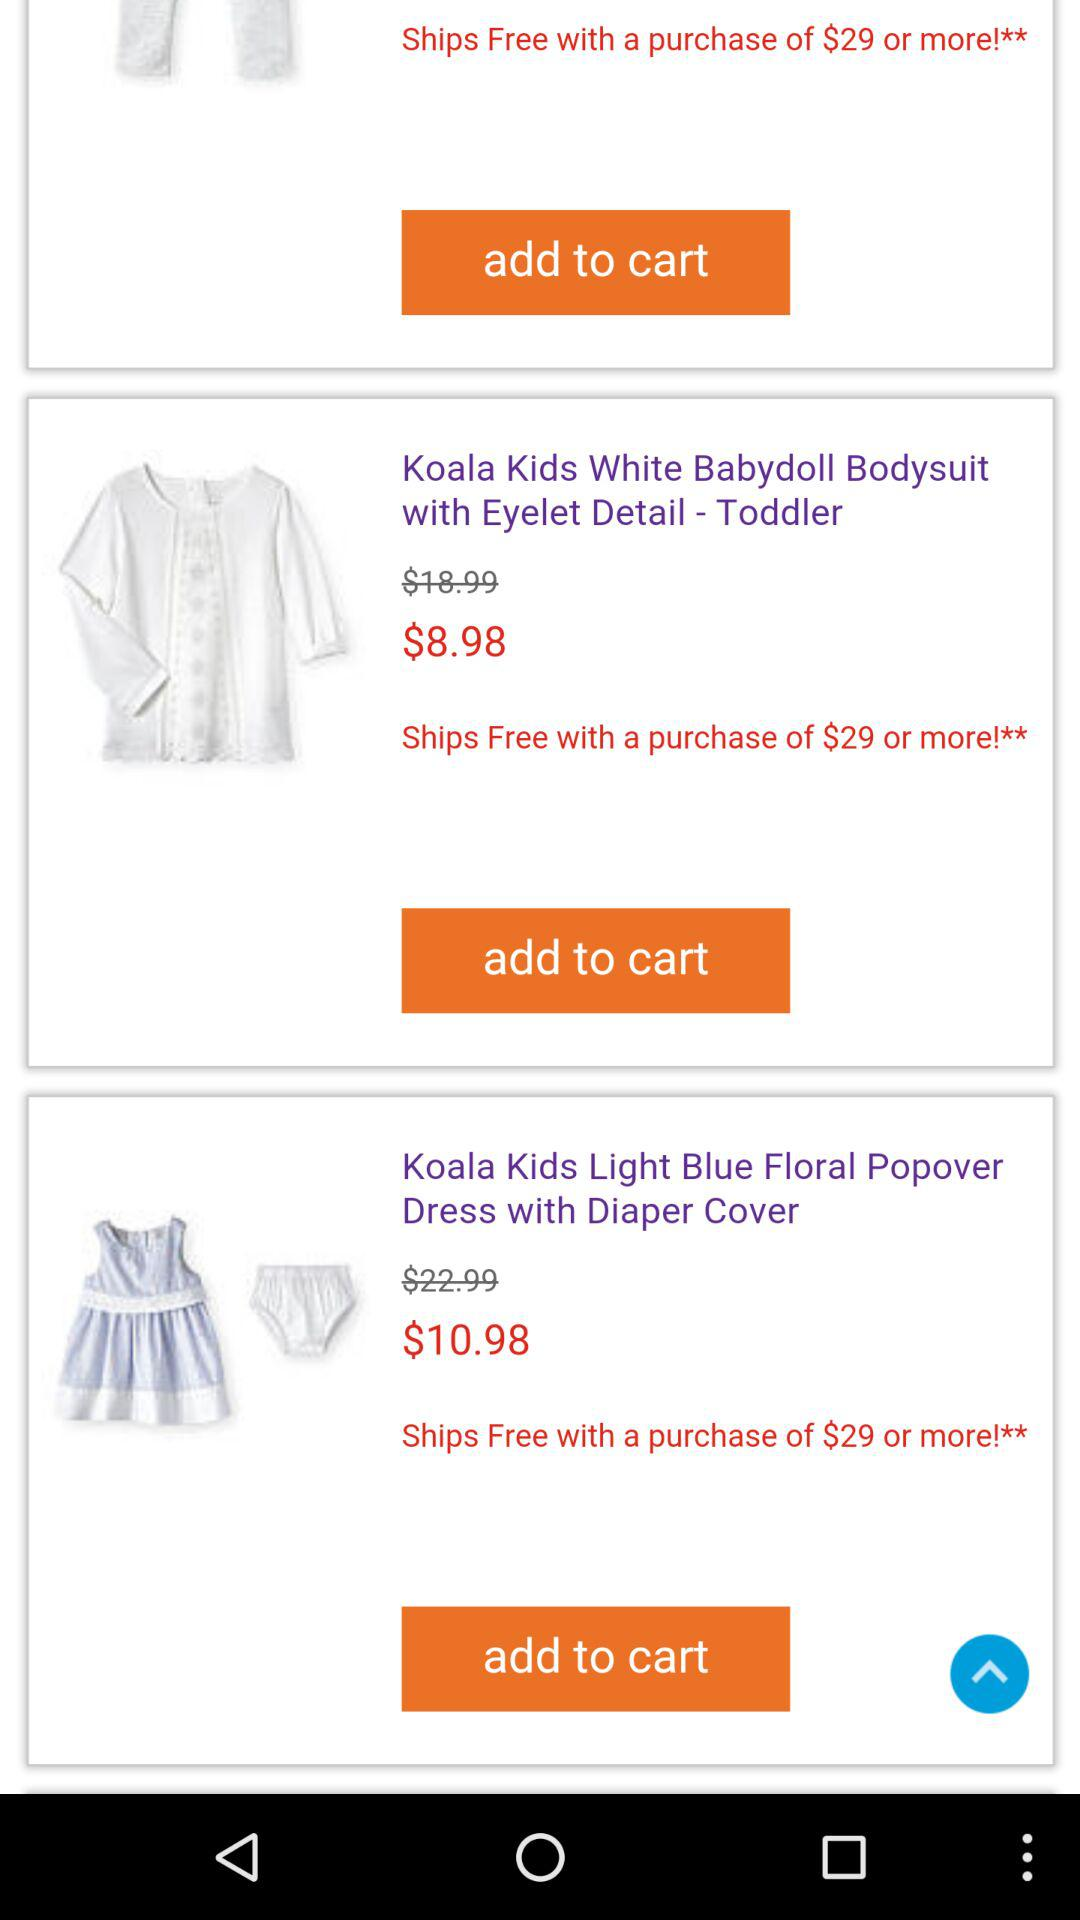On what order amount would shipping be free? Shipping would be free on the order amount of $29 or more. 